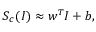Convert formula to latex. <formula><loc_0><loc_0><loc_500><loc_500>S _ { c } ( I ) \approx w ^ { T } I + b ,</formula> 